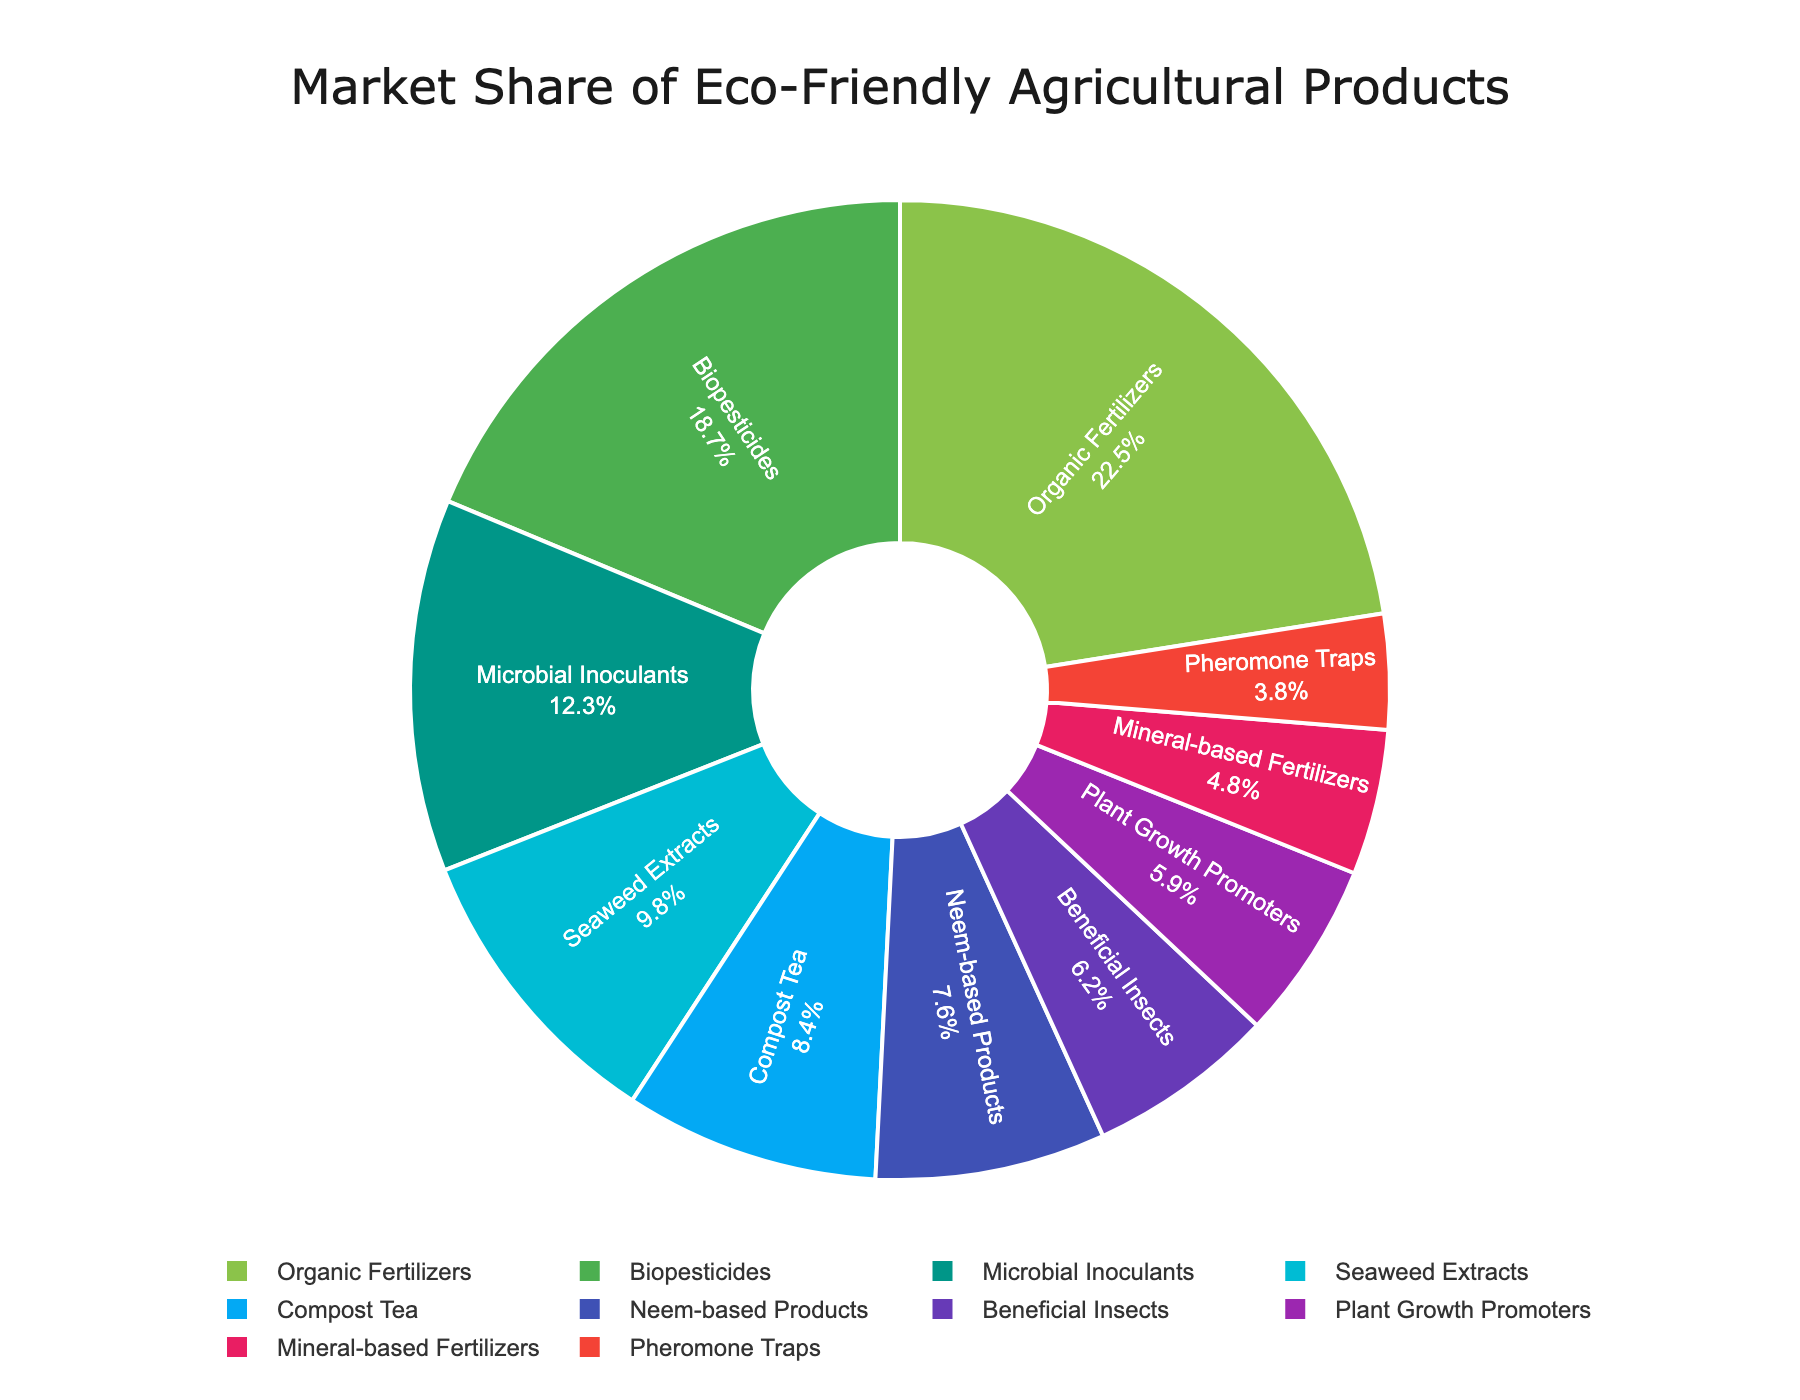What product has the largest market share? The figure shows a pie chart with different segments representing various products. The largest segment corresponds to Organic Fertilizers, which has the largest market share.
Answer: Organic Fertilizers Which product has the smallest market share? The figure’s pie chart has different segments, with the smallest segment corresponding to Pheromone Traps, indicating it has the smallest market share.
Answer: Pheromone Traps What is the combined market share of Organic Fertilizers and Biopesticides? From the figure, Organic Fertilizers have a market share of 22.5%, and Biopesticides have 18.7%. Adding these together results in a combined market share. 22.5% + 18.7% = 41.2%
Answer: 41.2% Which product has a greater market share: Plant Growth Promoters or Mineral-based Fertilizers? By comparing the segments in the figure, Plant Growth Promoters have a 5.9% market share, while Mineral-based Fertilizers have 4.8%. Plant Growth Promoters have a greater market share.
Answer: Plant Growth Promoters What is the average market share of the products shown in the pie chart? There are 10 product shares shown in the pie chart: 22.5, 18.7, 12.3, 9.8, 8.4, 7.6, 6.2, 5.9, 4.8, 3.8. Summing these values and dividing by the number of products gives the average. (22.5 + 18.7 + 12.3 + 9.8 + 8.4 + 7.6 + 6.2 + 5.9 + 4.8 + 3.8) / 10 = 9
Answer: 9% How much greater is the market share of Organic Fertilizers compared to Biopesticides? Organic Fertilizers have a market share of 22.5%, and Biopesticides have 18.7%. The difference between these two is calculated as 22.5% - 18.7% = 3.8%
Answer: 3.8% Which product segment is represented by the blue color in the pie chart? The segments in the pie chart are color-coded, and the blue segment corresponds to Seaweed Extracts.
Answer: Seaweed Extracts If you combine the market shares of Compost Tea, Neem-based Products, and Beneficial Insects, what is the total? From the figure, the market shares of Compost Tea, Neem-based Products, and Beneficial Insects are 8.4%, 7.6%, and 6.2%, respectively. Adding these together: 8.4% + 7.6% + 6.2% = 22.2%
Answer: 22.2% What is the market share difference between the product with the highest share and the product with the lowest share? Organic Fertilizers have the highest market share at 22.5%, and Pheromone Traps have the lowest at 3.8%. The difference is 22.5% - 3.8% = 18.7%
Answer: 18.7% Which product has a market share closest to 10%? The pie chart shows various product market shares, with Seaweed Extracts having a market share of 9.8%, which is closest to 10%.
Answer: Seaweed Extracts 